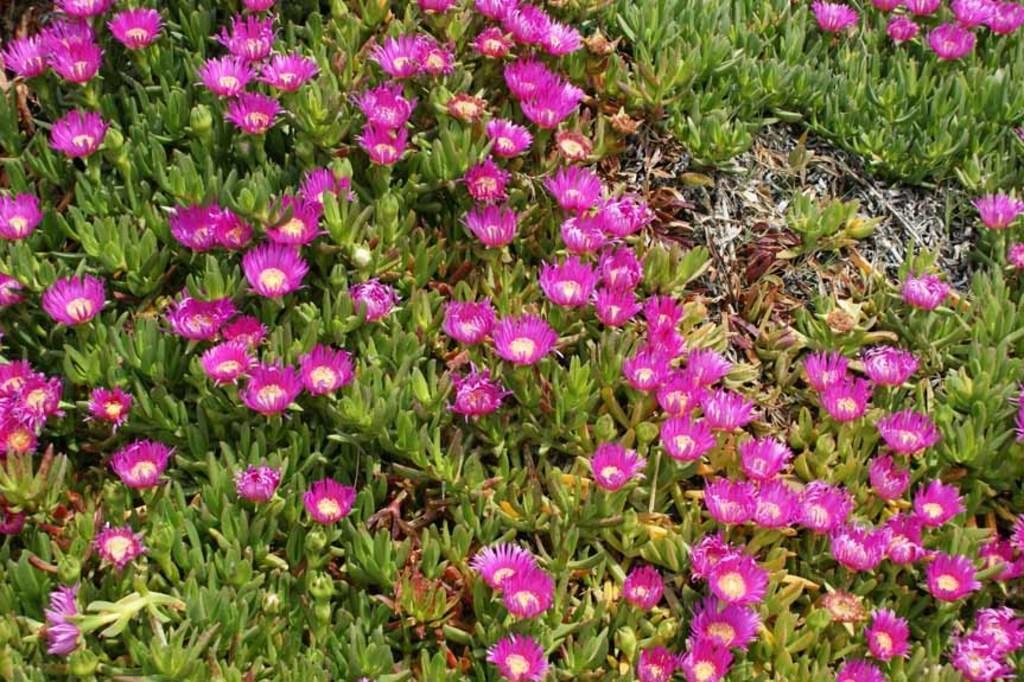Could you give a brief overview of what you see in this image? In this image I can see few flowers in pink color and I can see few plants in green color. 